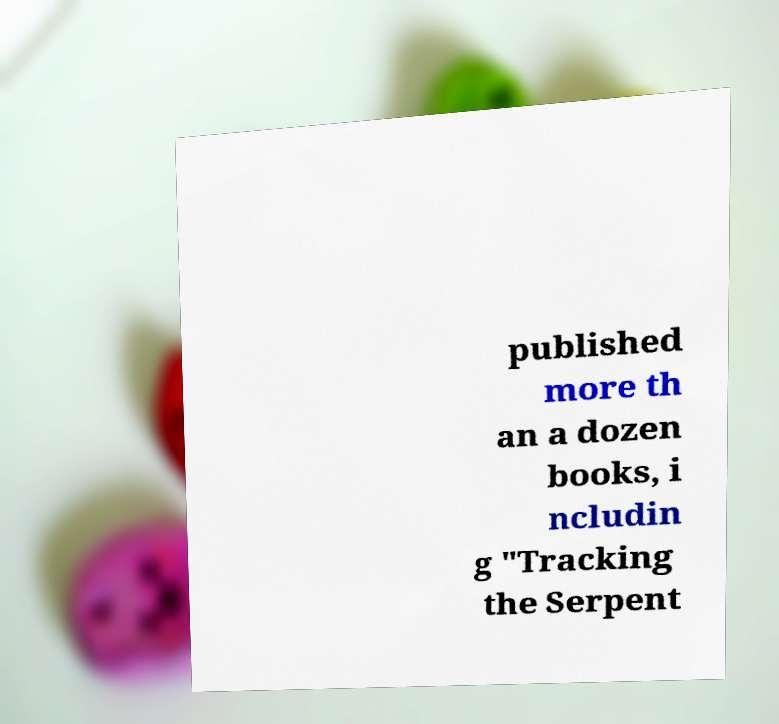What messages or text are displayed in this image? I need them in a readable, typed format. published more th an a dozen books, i ncludin g "Tracking the Serpent 